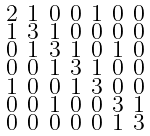Convert formula to latex. <formula><loc_0><loc_0><loc_500><loc_500>\begin{smallmatrix} 2 & 1 & 0 & 0 & 1 & 0 & 0 \\ 1 & 3 & 1 & 0 & 0 & 0 & 0 \\ 0 & 1 & 3 & 1 & 0 & 1 & 0 \\ 0 & 0 & 1 & 3 & 1 & 0 & 0 \\ 1 & 0 & 0 & 1 & 3 & 0 & 0 \\ 0 & 0 & 1 & 0 & 0 & 3 & 1 \\ 0 & 0 & 0 & 0 & 0 & 1 & 3 \end{smallmatrix}</formula> 